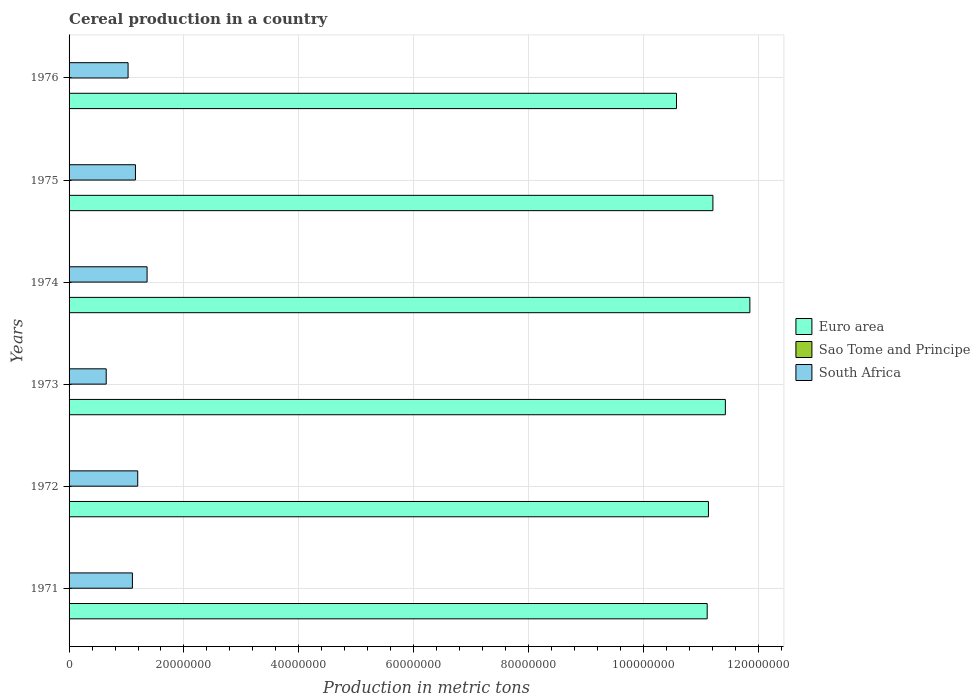How many bars are there on the 6th tick from the bottom?
Ensure brevity in your answer.  3. What is the label of the 2nd group of bars from the top?
Give a very brief answer. 1975. What is the total cereal production in Sao Tome and Principe in 1972?
Offer a terse response. 500. Across all years, what is the maximum total cereal production in Sao Tome and Principe?
Provide a short and direct response. 550. Across all years, what is the minimum total cereal production in Sao Tome and Principe?
Make the answer very short. 480. In which year was the total cereal production in South Africa maximum?
Your answer should be compact. 1974. In which year was the total cereal production in Sao Tome and Principe minimum?
Provide a succinct answer. 1971. What is the total total cereal production in Euro area in the graph?
Your response must be concise. 6.73e+08. What is the difference between the total cereal production in South Africa in 1971 and that in 1975?
Provide a succinct answer. -5.30e+05. What is the difference between the total cereal production in Sao Tome and Principe in 1971 and the total cereal production in South Africa in 1973?
Your response must be concise. -6.47e+06. What is the average total cereal production in Euro area per year?
Offer a terse response. 1.12e+08. In the year 1976, what is the difference between the total cereal production in South Africa and total cereal production in Sao Tome and Principe?
Your response must be concise. 1.03e+07. In how many years, is the total cereal production in Sao Tome and Principe greater than 104000000 metric tons?
Your response must be concise. 0. What is the ratio of the total cereal production in South Africa in 1972 to that in 1975?
Ensure brevity in your answer.  1.03. Is the difference between the total cereal production in South Africa in 1971 and 1976 greater than the difference between the total cereal production in Sao Tome and Principe in 1971 and 1976?
Make the answer very short. Yes. What is the difference between the highest and the second highest total cereal production in Euro area?
Your answer should be very brief. 4.27e+06. What is the difference between the highest and the lowest total cereal production in South Africa?
Your answer should be compact. 7.11e+06. In how many years, is the total cereal production in South Africa greater than the average total cereal production in South Africa taken over all years?
Keep it short and to the point. 4. Is the sum of the total cereal production in Euro area in 1974 and 1975 greater than the maximum total cereal production in Sao Tome and Principe across all years?
Your response must be concise. Yes. What does the 2nd bar from the top in 1974 represents?
Give a very brief answer. Sao Tome and Principe. What does the 2nd bar from the bottom in 1975 represents?
Give a very brief answer. Sao Tome and Principe. Is it the case that in every year, the sum of the total cereal production in Sao Tome and Principe and total cereal production in South Africa is greater than the total cereal production in Euro area?
Provide a succinct answer. No. Does the graph contain grids?
Offer a terse response. Yes. How are the legend labels stacked?
Your answer should be very brief. Vertical. What is the title of the graph?
Your answer should be very brief. Cereal production in a country. Does "Zambia" appear as one of the legend labels in the graph?
Ensure brevity in your answer.  No. What is the label or title of the X-axis?
Make the answer very short. Production in metric tons. What is the label or title of the Y-axis?
Your answer should be compact. Years. What is the Production in metric tons of Euro area in 1971?
Provide a succinct answer. 1.11e+08. What is the Production in metric tons of Sao Tome and Principe in 1971?
Your answer should be very brief. 480. What is the Production in metric tons in South Africa in 1971?
Keep it short and to the point. 1.10e+07. What is the Production in metric tons in Euro area in 1972?
Your response must be concise. 1.11e+08. What is the Production in metric tons of South Africa in 1972?
Offer a terse response. 1.20e+07. What is the Production in metric tons in Euro area in 1973?
Ensure brevity in your answer.  1.14e+08. What is the Production in metric tons in Sao Tome and Principe in 1973?
Offer a very short reply. 520. What is the Production in metric tons of South Africa in 1973?
Keep it short and to the point. 6.47e+06. What is the Production in metric tons of Euro area in 1974?
Ensure brevity in your answer.  1.19e+08. What is the Production in metric tons in Sao Tome and Principe in 1974?
Keep it short and to the point. 530. What is the Production in metric tons of South Africa in 1974?
Offer a terse response. 1.36e+07. What is the Production in metric tons of Euro area in 1975?
Provide a short and direct response. 1.12e+08. What is the Production in metric tons in Sao Tome and Principe in 1975?
Offer a very short reply. 550. What is the Production in metric tons of South Africa in 1975?
Keep it short and to the point. 1.16e+07. What is the Production in metric tons in Euro area in 1976?
Your response must be concise. 1.06e+08. What is the Production in metric tons in South Africa in 1976?
Your response must be concise. 1.03e+07. Across all years, what is the maximum Production in metric tons in Euro area?
Offer a very short reply. 1.19e+08. Across all years, what is the maximum Production in metric tons in Sao Tome and Principe?
Ensure brevity in your answer.  550. Across all years, what is the maximum Production in metric tons of South Africa?
Your answer should be very brief. 1.36e+07. Across all years, what is the minimum Production in metric tons of Euro area?
Ensure brevity in your answer.  1.06e+08. Across all years, what is the minimum Production in metric tons of Sao Tome and Principe?
Give a very brief answer. 480. Across all years, what is the minimum Production in metric tons of South Africa?
Offer a terse response. 6.47e+06. What is the total Production in metric tons in Euro area in the graph?
Your response must be concise. 6.73e+08. What is the total Production in metric tons of Sao Tome and Principe in the graph?
Provide a succinct answer. 3080. What is the total Production in metric tons of South Africa in the graph?
Offer a terse response. 6.49e+07. What is the difference between the Production in metric tons in Euro area in 1971 and that in 1972?
Provide a succinct answer. -2.17e+05. What is the difference between the Production in metric tons in South Africa in 1971 and that in 1972?
Provide a succinct answer. -9.23e+05. What is the difference between the Production in metric tons in Euro area in 1971 and that in 1973?
Make the answer very short. -3.16e+06. What is the difference between the Production in metric tons in Sao Tome and Principe in 1971 and that in 1973?
Provide a succinct answer. -40. What is the difference between the Production in metric tons in South Africa in 1971 and that in 1973?
Offer a terse response. 4.56e+06. What is the difference between the Production in metric tons of Euro area in 1971 and that in 1974?
Offer a very short reply. -7.43e+06. What is the difference between the Production in metric tons of Sao Tome and Principe in 1971 and that in 1974?
Ensure brevity in your answer.  -50. What is the difference between the Production in metric tons of South Africa in 1971 and that in 1974?
Make the answer very short. -2.55e+06. What is the difference between the Production in metric tons in Euro area in 1971 and that in 1975?
Your answer should be compact. -9.96e+05. What is the difference between the Production in metric tons in Sao Tome and Principe in 1971 and that in 1975?
Keep it short and to the point. -70. What is the difference between the Production in metric tons in South Africa in 1971 and that in 1975?
Provide a short and direct response. -5.30e+05. What is the difference between the Production in metric tons in Euro area in 1971 and that in 1976?
Provide a succinct answer. 5.34e+06. What is the difference between the Production in metric tons in Sao Tome and Principe in 1971 and that in 1976?
Provide a short and direct response. -20. What is the difference between the Production in metric tons in South Africa in 1971 and that in 1976?
Make the answer very short. 7.55e+05. What is the difference between the Production in metric tons of Euro area in 1972 and that in 1973?
Give a very brief answer. -2.94e+06. What is the difference between the Production in metric tons in Sao Tome and Principe in 1972 and that in 1973?
Make the answer very short. -20. What is the difference between the Production in metric tons of South Africa in 1972 and that in 1973?
Offer a very short reply. 5.48e+06. What is the difference between the Production in metric tons of Euro area in 1972 and that in 1974?
Make the answer very short. -7.21e+06. What is the difference between the Production in metric tons of Sao Tome and Principe in 1972 and that in 1974?
Your answer should be compact. -30. What is the difference between the Production in metric tons of South Africa in 1972 and that in 1974?
Provide a short and direct response. -1.63e+06. What is the difference between the Production in metric tons of Euro area in 1972 and that in 1975?
Offer a terse response. -7.79e+05. What is the difference between the Production in metric tons in South Africa in 1972 and that in 1975?
Provide a short and direct response. 3.93e+05. What is the difference between the Production in metric tons of Euro area in 1972 and that in 1976?
Keep it short and to the point. 5.56e+06. What is the difference between the Production in metric tons in Sao Tome and Principe in 1972 and that in 1976?
Ensure brevity in your answer.  0. What is the difference between the Production in metric tons in South Africa in 1972 and that in 1976?
Give a very brief answer. 1.68e+06. What is the difference between the Production in metric tons of Euro area in 1973 and that in 1974?
Provide a short and direct response. -4.27e+06. What is the difference between the Production in metric tons in Sao Tome and Principe in 1973 and that in 1974?
Your response must be concise. -10. What is the difference between the Production in metric tons in South Africa in 1973 and that in 1974?
Provide a succinct answer. -7.11e+06. What is the difference between the Production in metric tons of Euro area in 1973 and that in 1975?
Make the answer very short. 2.17e+06. What is the difference between the Production in metric tons in Sao Tome and Principe in 1973 and that in 1975?
Give a very brief answer. -30. What is the difference between the Production in metric tons of South Africa in 1973 and that in 1975?
Your answer should be compact. -5.09e+06. What is the difference between the Production in metric tons of Euro area in 1973 and that in 1976?
Keep it short and to the point. 8.51e+06. What is the difference between the Production in metric tons in South Africa in 1973 and that in 1976?
Offer a terse response. -3.81e+06. What is the difference between the Production in metric tons of Euro area in 1974 and that in 1975?
Ensure brevity in your answer.  6.43e+06. What is the difference between the Production in metric tons in Sao Tome and Principe in 1974 and that in 1975?
Ensure brevity in your answer.  -20. What is the difference between the Production in metric tons in South Africa in 1974 and that in 1975?
Make the answer very short. 2.02e+06. What is the difference between the Production in metric tons of Euro area in 1974 and that in 1976?
Ensure brevity in your answer.  1.28e+07. What is the difference between the Production in metric tons in South Africa in 1974 and that in 1976?
Ensure brevity in your answer.  3.31e+06. What is the difference between the Production in metric tons in Euro area in 1975 and that in 1976?
Ensure brevity in your answer.  6.34e+06. What is the difference between the Production in metric tons of Sao Tome and Principe in 1975 and that in 1976?
Give a very brief answer. 50. What is the difference between the Production in metric tons of South Africa in 1975 and that in 1976?
Ensure brevity in your answer.  1.28e+06. What is the difference between the Production in metric tons in Euro area in 1971 and the Production in metric tons in Sao Tome and Principe in 1972?
Offer a terse response. 1.11e+08. What is the difference between the Production in metric tons of Euro area in 1971 and the Production in metric tons of South Africa in 1972?
Give a very brief answer. 9.91e+07. What is the difference between the Production in metric tons in Sao Tome and Principe in 1971 and the Production in metric tons in South Africa in 1972?
Your response must be concise. -1.20e+07. What is the difference between the Production in metric tons in Euro area in 1971 and the Production in metric tons in Sao Tome and Principe in 1973?
Provide a short and direct response. 1.11e+08. What is the difference between the Production in metric tons in Euro area in 1971 and the Production in metric tons in South Africa in 1973?
Give a very brief answer. 1.05e+08. What is the difference between the Production in metric tons of Sao Tome and Principe in 1971 and the Production in metric tons of South Africa in 1973?
Provide a succinct answer. -6.47e+06. What is the difference between the Production in metric tons in Euro area in 1971 and the Production in metric tons in Sao Tome and Principe in 1974?
Provide a short and direct response. 1.11e+08. What is the difference between the Production in metric tons in Euro area in 1971 and the Production in metric tons in South Africa in 1974?
Make the answer very short. 9.75e+07. What is the difference between the Production in metric tons of Sao Tome and Principe in 1971 and the Production in metric tons of South Africa in 1974?
Offer a terse response. -1.36e+07. What is the difference between the Production in metric tons of Euro area in 1971 and the Production in metric tons of Sao Tome and Principe in 1975?
Offer a very short reply. 1.11e+08. What is the difference between the Production in metric tons in Euro area in 1971 and the Production in metric tons in South Africa in 1975?
Offer a terse response. 9.95e+07. What is the difference between the Production in metric tons of Sao Tome and Principe in 1971 and the Production in metric tons of South Africa in 1975?
Ensure brevity in your answer.  -1.16e+07. What is the difference between the Production in metric tons in Euro area in 1971 and the Production in metric tons in Sao Tome and Principe in 1976?
Keep it short and to the point. 1.11e+08. What is the difference between the Production in metric tons of Euro area in 1971 and the Production in metric tons of South Africa in 1976?
Make the answer very short. 1.01e+08. What is the difference between the Production in metric tons of Sao Tome and Principe in 1971 and the Production in metric tons of South Africa in 1976?
Make the answer very short. -1.03e+07. What is the difference between the Production in metric tons in Euro area in 1972 and the Production in metric tons in Sao Tome and Principe in 1973?
Ensure brevity in your answer.  1.11e+08. What is the difference between the Production in metric tons of Euro area in 1972 and the Production in metric tons of South Africa in 1973?
Your answer should be very brief. 1.05e+08. What is the difference between the Production in metric tons in Sao Tome and Principe in 1972 and the Production in metric tons in South Africa in 1973?
Keep it short and to the point. -6.47e+06. What is the difference between the Production in metric tons of Euro area in 1972 and the Production in metric tons of Sao Tome and Principe in 1974?
Provide a short and direct response. 1.11e+08. What is the difference between the Production in metric tons of Euro area in 1972 and the Production in metric tons of South Africa in 1974?
Provide a succinct answer. 9.77e+07. What is the difference between the Production in metric tons of Sao Tome and Principe in 1972 and the Production in metric tons of South Africa in 1974?
Your response must be concise. -1.36e+07. What is the difference between the Production in metric tons of Euro area in 1972 and the Production in metric tons of Sao Tome and Principe in 1975?
Your answer should be compact. 1.11e+08. What is the difference between the Production in metric tons of Euro area in 1972 and the Production in metric tons of South Africa in 1975?
Make the answer very short. 9.98e+07. What is the difference between the Production in metric tons in Sao Tome and Principe in 1972 and the Production in metric tons in South Africa in 1975?
Give a very brief answer. -1.16e+07. What is the difference between the Production in metric tons in Euro area in 1972 and the Production in metric tons in Sao Tome and Principe in 1976?
Your response must be concise. 1.11e+08. What is the difference between the Production in metric tons of Euro area in 1972 and the Production in metric tons of South Africa in 1976?
Make the answer very short. 1.01e+08. What is the difference between the Production in metric tons in Sao Tome and Principe in 1972 and the Production in metric tons in South Africa in 1976?
Your answer should be very brief. -1.03e+07. What is the difference between the Production in metric tons in Euro area in 1973 and the Production in metric tons in Sao Tome and Principe in 1974?
Your answer should be compact. 1.14e+08. What is the difference between the Production in metric tons of Euro area in 1973 and the Production in metric tons of South Africa in 1974?
Your answer should be compact. 1.01e+08. What is the difference between the Production in metric tons in Sao Tome and Principe in 1973 and the Production in metric tons in South Africa in 1974?
Make the answer very short. -1.36e+07. What is the difference between the Production in metric tons of Euro area in 1973 and the Production in metric tons of Sao Tome and Principe in 1975?
Your answer should be very brief. 1.14e+08. What is the difference between the Production in metric tons of Euro area in 1973 and the Production in metric tons of South Africa in 1975?
Ensure brevity in your answer.  1.03e+08. What is the difference between the Production in metric tons of Sao Tome and Principe in 1973 and the Production in metric tons of South Africa in 1975?
Make the answer very short. -1.16e+07. What is the difference between the Production in metric tons of Euro area in 1973 and the Production in metric tons of Sao Tome and Principe in 1976?
Provide a short and direct response. 1.14e+08. What is the difference between the Production in metric tons of Euro area in 1973 and the Production in metric tons of South Africa in 1976?
Offer a very short reply. 1.04e+08. What is the difference between the Production in metric tons in Sao Tome and Principe in 1973 and the Production in metric tons in South Africa in 1976?
Keep it short and to the point. -1.03e+07. What is the difference between the Production in metric tons in Euro area in 1974 and the Production in metric tons in Sao Tome and Principe in 1975?
Your response must be concise. 1.19e+08. What is the difference between the Production in metric tons of Euro area in 1974 and the Production in metric tons of South Africa in 1975?
Your answer should be compact. 1.07e+08. What is the difference between the Production in metric tons in Sao Tome and Principe in 1974 and the Production in metric tons in South Africa in 1975?
Make the answer very short. -1.16e+07. What is the difference between the Production in metric tons in Euro area in 1974 and the Production in metric tons in Sao Tome and Principe in 1976?
Give a very brief answer. 1.19e+08. What is the difference between the Production in metric tons in Euro area in 1974 and the Production in metric tons in South Africa in 1976?
Your response must be concise. 1.08e+08. What is the difference between the Production in metric tons in Sao Tome and Principe in 1974 and the Production in metric tons in South Africa in 1976?
Ensure brevity in your answer.  -1.03e+07. What is the difference between the Production in metric tons of Euro area in 1975 and the Production in metric tons of Sao Tome and Principe in 1976?
Give a very brief answer. 1.12e+08. What is the difference between the Production in metric tons in Euro area in 1975 and the Production in metric tons in South Africa in 1976?
Make the answer very short. 1.02e+08. What is the difference between the Production in metric tons of Sao Tome and Principe in 1975 and the Production in metric tons of South Africa in 1976?
Give a very brief answer. -1.03e+07. What is the average Production in metric tons of Euro area per year?
Provide a succinct answer. 1.12e+08. What is the average Production in metric tons of Sao Tome and Principe per year?
Your answer should be compact. 513.33. What is the average Production in metric tons of South Africa per year?
Make the answer very short. 1.08e+07. In the year 1971, what is the difference between the Production in metric tons in Euro area and Production in metric tons in Sao Tome and Principe?
Offer a very short reply. 1.11e+08. In the year 1971, what is the difference between the Production in metric tons in Euro area and Production in metric tons in South Africa?
Give a very brief answer. 1.00e+08. In the year 1971, what is the difference between the Production in metric tons in Sao Tome and Principe and Production in metric tons in South Africa?
Make the answer very short. -1.10e+07. In the year 1972, what is the difference between the Production in metric tons in Euro area and Production in metric tons in Sao Tome and Principe?
Your answer should be very brief. 1.11e+08. In the year 1972, what is the difference between the Production in metric tons in Euro area and Production in metric tons in South Africa?
Your answer should be very brief. 9.94e+07. In the year 1972, what is the difference between the Production in metric tons in Sao Tome and Principe and Production in metric tons in South Africa?
Ensure brevity in your answer.  -1.20e+07. In the year 1973, what is the difference between the Production in metric tons of Euro area and Production in metric tons of Sao Tome and Principe?
Offer a terse response. 1.14e+08. In the year 1973, what is the difference between the Production in metric tons in Euro area and Production in metric tons in South Africa?
Provide a short and direct response. 1.08e+08. In the year 1973, what is the difference between the Production in metric tons of Sao Tome and Principe and Production in metric tons of South Africa?
Your answer should be compact. -6.47e+06. In the year 1974, what is the difference between the Production in metric tons of Euro area and Production in metric tons of Sao Tome and Principe?
Make the answer very short. 1.19e+08. In the year 1974, what is the difference between the Production in metric tons of Euro area and Production in metric tons of South Africa?
Keep it short and to the point. 1.05e+08. In the year 1974, what is the difference between the Production in metric tons in Sao Tome and Principe and Production in metric tons in South Africa?
Offer a terse response. -1.36e+07. In the year 1975, what is the difference between the Production in metric tons in Euro area and Production in metric tons in Sao Tome and Principe?
Offer a terse response. 1.12e+08. In the year 1975, what is the difference between the Production in metric tons in Euro area and Production in metric tons in South Africa?
Your response must be concise. 1.01e+08. In the year 1975, what is the difference between the Production in metric tons of Sao Tome and Principe and Production in metric tons of South Africa?
Provide a short and direct response. -1.16e+07. In the year 1976, what is the difference between the Production in metric tons in Euro area and Production in metric tons in Sao Tome and Principe?
Offer a terse response. 1.06e+08. In the year 1976, what is the difference between the Production in metric tons of Euro area and Production in metric tons of South Africa?
Ensure brevity in your answer.  9.55e+07. In the year 1976, what is the difference between the Production in metric tons of Sao Tome and Principe and Production in metric tons of South Africa?
Give a very brief answer. -1.03e+07. What is the ratio of the Production in metric tons of Euro area in 1971 to that in 1972?
Offer a very short reply. 1. What is the ratio of the Production in metric tons in South Africa in 1971 to that in 1972?
Keep it short and to the point. 0.92. What is the ratio of the Production in metric tons of Euro area in 1971 to that in 1973?
Keep it short and to the point. 0.97. What is the ratio of the Production in metric tons in South Africa in 1971 to that in 1973?
Keep it short and to the point. 1.71. What is the ratio of the Production in metric tons of Euro area in 1971 to that in 1974?
Offer a terse response. 0.94. What is the ratio of the Production in metric tons of Sao Tome and Principe in 1971 to that in 1974?
Keep it short and to the point. 0.91. What is the ratio of the Production in metric tons in South Africa in 1971 to that in 1974?
Your answer should be compact. 0.81. What is the ratio of the Production in metric tons in Sao Tome and Principe in 1971 to that in 1975?
Keep it short and to the point. 0.87. What is the ratio of the Production in metric tons in South Africa in 1971 to that in 1975?
Offer a terse response. 0.95. What is the ratio of the Production in metric tons of Euro area in 1971 to that in 1976?
Keep it short and to the point. 1.05. What is the ratio of the Production in metric tons of South Africa in 1971 to that in 1976?
Offer a very short reply. 1.07. What is the ratio of the Production in metric tons in Euro area in 1972 to that in 1973?
Offer a terse response. 0.97. What is the ratio of the Production in metric tons of Sao Tome and Principe in 1972 to that in 1973?
Provide a succinct answer. 0.96. What is the ratio of the Production in metric tons of South Africa in 1972 to that in 1973?
Offer a terse response. 1.85. What is the ratio of the Production in metric tons in Euro area in 1972 to that in 1974?
Provide a short and direct response. 0.94. What is the ratio of the Production in metric tons in Sao Tome and Principe in 1972 to that in 1974?
Provide a short and direct response. 0.94. What is the ratio of the Production in metric tons in Euro area in 1972 to that in 1975?
Provide a succinct answer. 0.99. What is the ratio of the Production in metric tons of Sao Tome and Principe in 1972 to that in 1975?
Offer a very short reply. 0.91. What is the ratio of the Production in metric tons in South Africa in 1972 to that in 1975?
Offer a very short reply. 1.03. What is the ratio of the Production in metric tons in Euro area in 1972 to that in 1976?
Your response must be concise. 1.05. What is the ratio of the Production in metric tons of Sao Tome and Principe in 1972 to that in 1976?
Your response must be concise. 1. What is the ratio of the Production in metric tons in South Africa in 1972 to that in 1976?
Keep it short and to the point. 1.16. What is the ratio of the Production in metric tons in Euro area in 1973 to that in 1974?
Ensure brevity in your answer.  0.96. What is the ratio of the Production in metric tons of Sao Tome and Principe in 1973 to that in 1974?
Your response must be concise. 0.98. What is the ratio of the Production in metric tons of South Africa in 1973 to that in 1974?
Your response must be concise. 0.48. What is the ratio of the Production in metric tons of Euro area in 1973 to that in 1975?
Make the answer very short. 1.02. What is the ratio of the Production in metric tons in Sao Tome and Principe in 1973 to that in 1975?
Your answer should be very brief. 0.95. What is the ratio of the Production in metric tons of South Africa in 1973 to that in 1975?
Your answer should be compact. 0.56. What is the ratio of the Production in metric tons of Euro area in 1973 to that in 1976?
Your answer should be compact. 1.08. What is the ratio of the Production in metric tons of South Africa in 1973 to that in 1976?
Your answer should be compact. 0.63. What is the ratio of the Production in metric tons in Euro area in 1974 to that in 1975?
Keep it short and to the point. 1.06. What is the ratio of the Production in metric tons in Sao Tome and Principe in 1974 to that in 1975?
Make the answer very short. 0.96. What is the ratio of the Production in metric tons in South Africa in 1974 to that in 1975?
Your answer should be compact. 1.17. What is the ratio of the Production in metric tons of Euro area in 1974 to that in 1976?
Provide a short and direct response. 1.12. What is the ratio of the Production in metric tons in Sao Tome and Principe in 1974 to that in 1976?
Make the answer very short. 1.06. What is the ratio of the Production in metric tons of South Africa in 1974 to that in 1976?
Give a very brief answer. 1.32. What is the ratio of the Production in metric tons of Euro area in 1975 to that in 1976?
Your answer should be very brief. 1.06. What is the ratio of the Production in metric tons in South Africa in 1975 to that in 1976?
Provide a short and direct response. 1.13. What is the difference between the highest and the second highest Production in metric tons of Euro area?
Keep it short and to the point. 4.27e+06. What is the difference between the highest and the second highest Production in metric tons of Sao Tome and Principe?
Make the answer very short. 20. What is the difference between the highest and the second highest Production in metric tons of South Africa?
Provide a succinct answer. 1.63e+06. What is the difference between the highest and the lowest Production in metric tons in Euro area?
Ensure brevity in your answer.  1.28e+07. What is the difference between the highest and the lowest Production in metric tons in South Africa?
Your answer should be compact. 7.11e+06. 